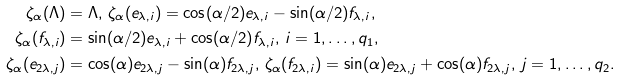Convert formula to latex. <formula><loc_0><loc_0><loc_500><loc_500>\zeta _ { \alpha } ( \Lambda ) & = \Lambda , \, \zeta _ { \alpha } ( e _ { \lambda , i } ) = \cos ( \alpha / 2 ) e _ { \lambda , i } - \sin ( \alpha / 2 ) f _ { \lambda , i } , \\ \zeta _ { \alpha } ( f _ { \lambda , i } ) & = \sin ( \alpha / 2 ) e _ { \lambda , i } + \cos ( \alpha / 2 ) f _ { \lambda , i } , \, i = 1 , \dots , q _ { 1 } , \\ \zeta _ { \alpha } ( e _ { 2 \lambda , j } ) & = \cos ( \alpha ) e _ { 2 \lambda , j } - \sin ( \alpha ) f _ { 2 \lambda , j } , \, \zeta _ { \alpha } ( f _ { 2 \lambda , i } ) = \sin ( \alpha ) e _ { 2 \lambda , j } + \cos ( \alpha ) f _ { 2 \lambda , j } , \, j = 1 , \dots , q _ { 2 } .</formula> 